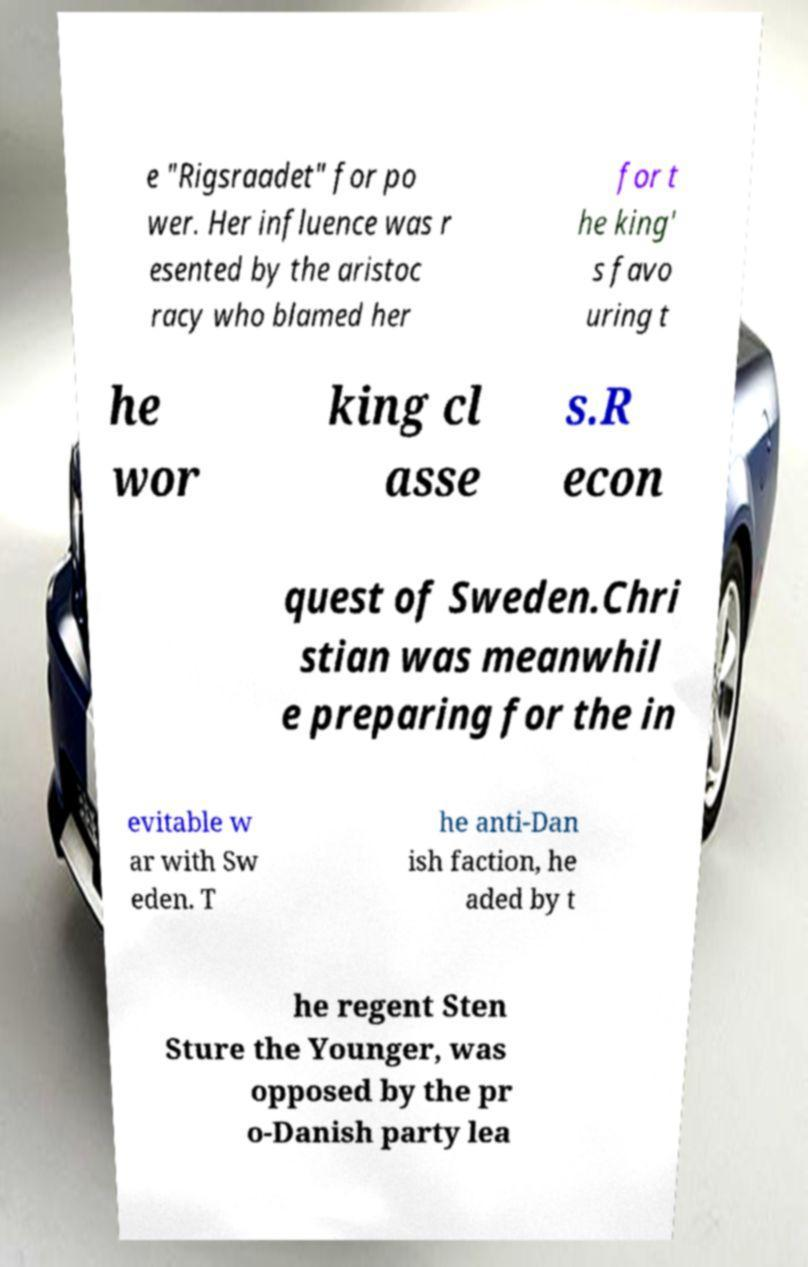What messages or text are displayed in this image? I need them in a readable, typed format. e "Rigsraadet" for po wer. Her influence was r esented by the aristoc racy who blamed her for t he king' s favo uring t he wor king cl asse s.R econ quest of Sweden.Chri stian was meanwhil e preparing for the in evitable w ar with Sw eden. T he anti-Dan ish faction, he aded by t he regent Sten Sture the Younger, was opposed by the pr o-Danish party lea 